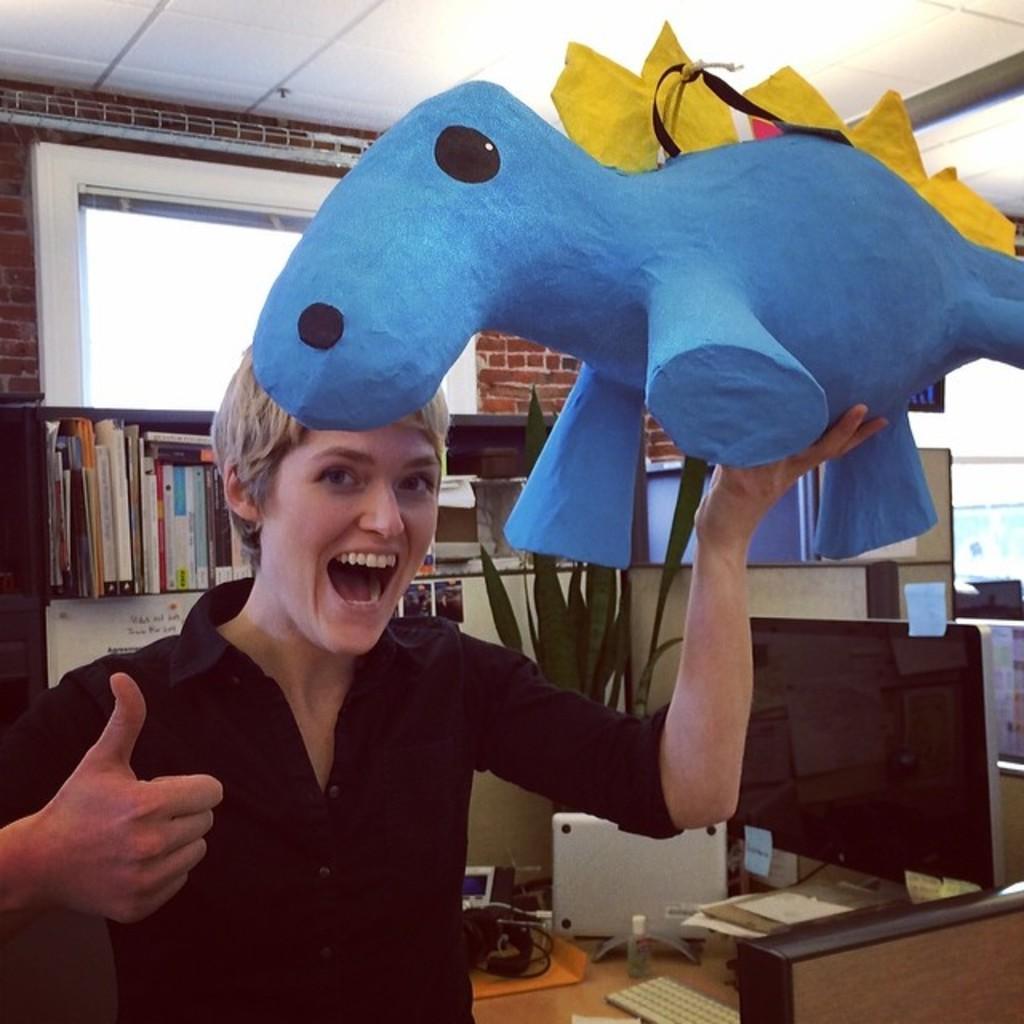Describe this image in one or two sentences. A person wearing a black dress is holding a toy. There is a table. On the table there is a system, keyboard, plant. In the background there is a cupboard. Inside cupboard there are books. There is a window and brick wall in the background. 